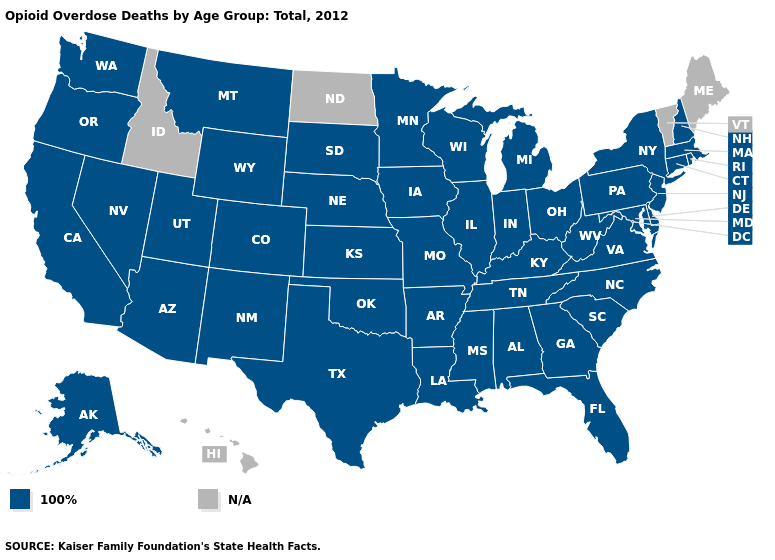How many symbols are there in the legend?
Be succinct. 2. Name the states that have a value in the range 100%?
Be succinct. Alabama, Alaska, Arizona, Arkansas, California, Colorado, Connecticut, Delaware, Florida, Georgia, Illinois, Indiana, Iowa, Kansas, Kentucky, Louisiana, Maryland, Massachusetts, Michigan, Minnesota, Mississippi, Missouri, Montana, Nebraska, Nevada, New Hampshire, New Jersey, New Mexico, New York, North Carolina, Ohio, Oklahoma, Oregon, Pennsylvania, Rhode Island, South Carolina, South Dakota, Tennessee, Texas, Utah, Virginia, Washington, West Virginia, Wisconsin, Wyoming. Name the states that have a value in the range N/A?
Quick response, please. Hawaii, Idaho, Maine, North Dakota, Vermont. Which states have the highest value in the USA?
Concise answer only. Alabama, Alaska, Arizona, Arkansas, California, Colorado, Connecticut, Delaware, Florida, Georgia, Illinois, Indiana, Iowa, Kansas, Kentucky, Louisiana, Maryland, Massachusetts, Michigan, Minnesota, Mississippi, Missouri, Montana, Nebraska, Nevada, New Hampshire, New Jersey, New Mexico, New York, North Carolina, Ohio, Oklahoma, Oregon, Pennsylvania, Rhode Island, South Carolina, South Dakota, Tennessee, Texas, Utah, Virginia, Washington, West Virginia, Wisconsin, Wyoming. Name the states that have a value in the range N/A?
Write a very short answer. Hawaii, Idaho, Maine, North Dakota, Vermont. Name the states that have a value in the range N/A?
Be succinct. Hawaii, Idaho, Maine, North Dakota, Vermont. Does the first symbol in the legend represent the smallest category?
Answer briefly. Yes. What is the value of Alabama?
Write a very short answer. 100%. Name the states that have a value in the range 100%?
Quick response, please. Alabama, Alaska, Arizona, Arkansas, California, Colorado, Connecticut, Delaware, Florida, Georgia, Illinois, Indiana, Iowa, Kansas, Kentucky, Louisiana, Maryland, Massachusetts, Michigan, Minnesota, Mississippi, Missouri, Montana, Nebraska, Nevada, New Hampshire, New Jersey, New Mexico, New York, North Carolina, Ohio, Oklahoma, Oregon, Pennsylvania, Rhode Island, South Carolina, South Dakota, Tennessee, Texas, Utah, Virginia, Washington, West Virginia, Wisconsin, Wyoming. Which states have the lowest value in the USA?
Give a very brief answer. Alabama, Alaska, Arizona, Arkansas, California, Colorado, Connecticut, Delaware, Florida, Georgia, Illinois, Indiana, Iowa, Kansas, Kentucky, Louisiana, Maryland, Massachusetts, Michigan, Minnesota, Mississippi, Missouri, Montana, Nebraska, Nevada, New Hampshire, New Jersey, New Mexico, New York, North Carolina, Ohio, Oklahoma, Oregon, Pennsylvania, Rhode Island, South Carolina, South Dakota, Tennessee, Texas, Utah, Virginia, Washington, West Virginia, Wisconsin, Wyoming. Does the first symbol in the legend represent the smallest category?
Short answer required. Yes. 